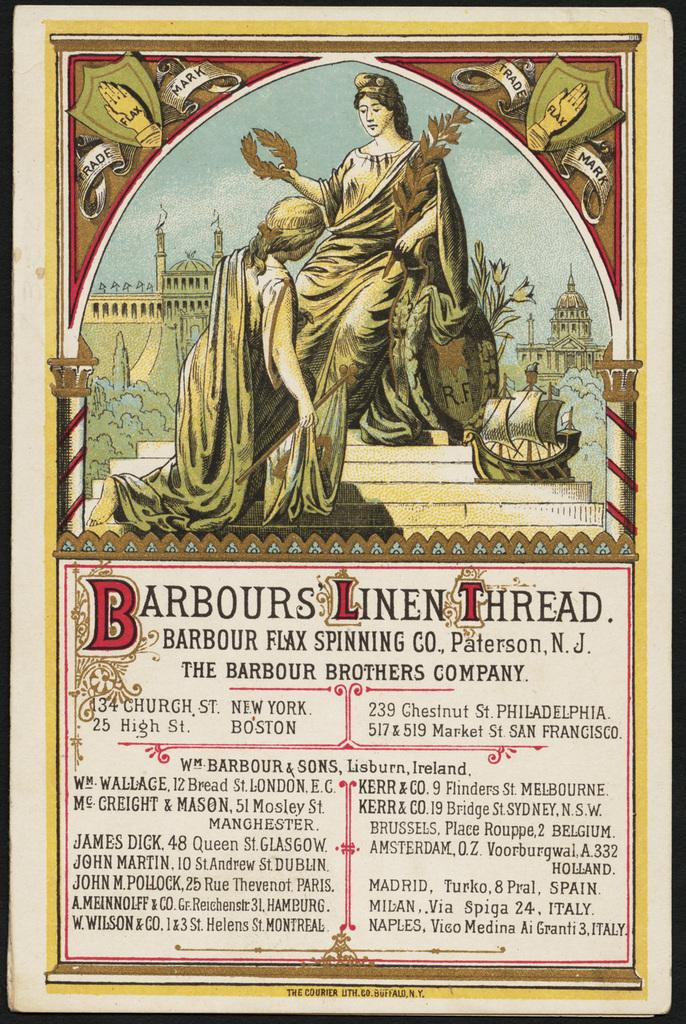<image>
Offer a succinct explanation of the picture presented. An advertisement that is for Barbours Linen Thread. 